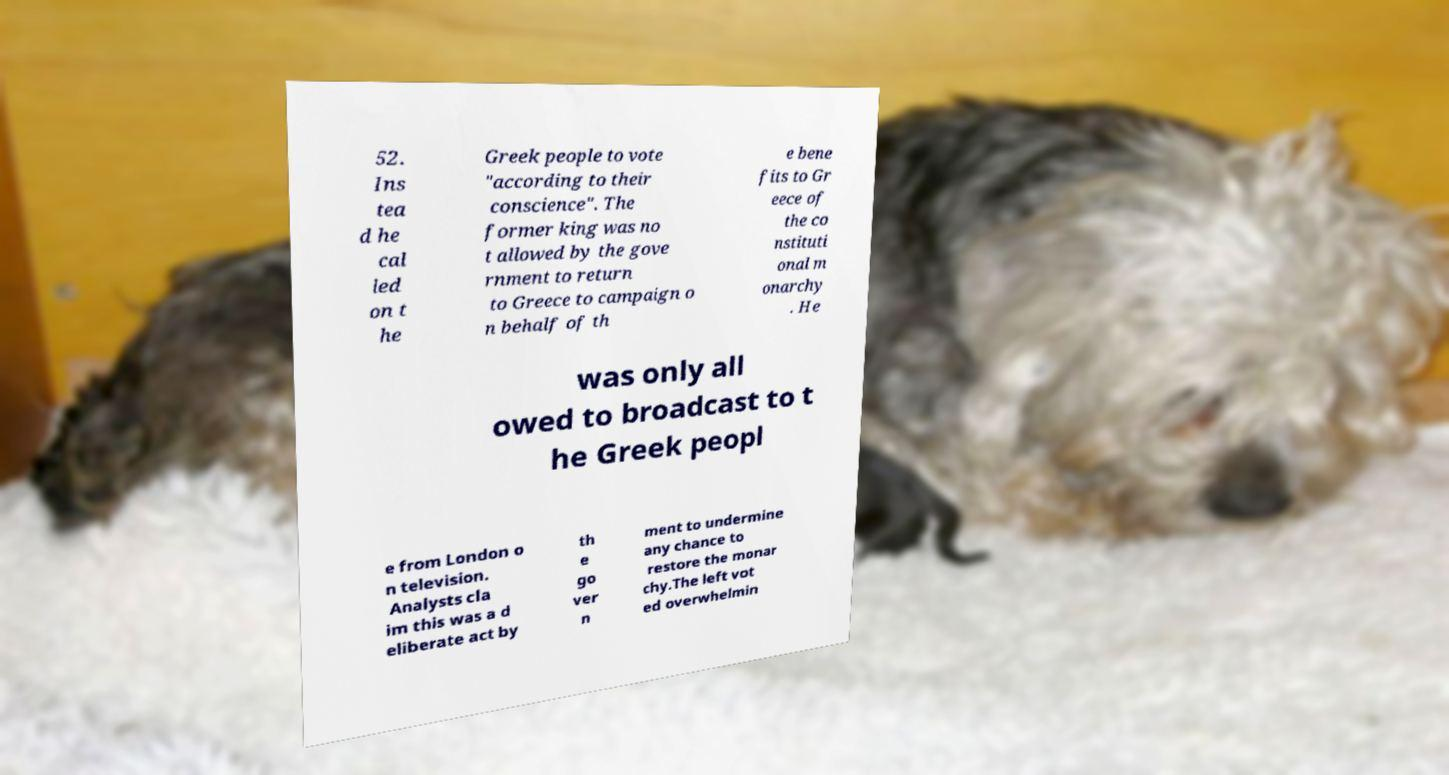Please identify and transcribe the text found in this image. 52. Ins tea d he cal led on t he Greek people to vote "according to their conscience". The former king was no t allowed by the gove rnment to return to Greece to campaign o n behalf of th e bene fits to Gr eece of the co nstituti onal m onarchy . He was only all owed to broadcast to t he Greek peopl e from London o n television. Analysts cla im this was a d eliberate act by th e go ver n ment to undermine any chance to restore the monar chy.The left vot ed overwhelmin 